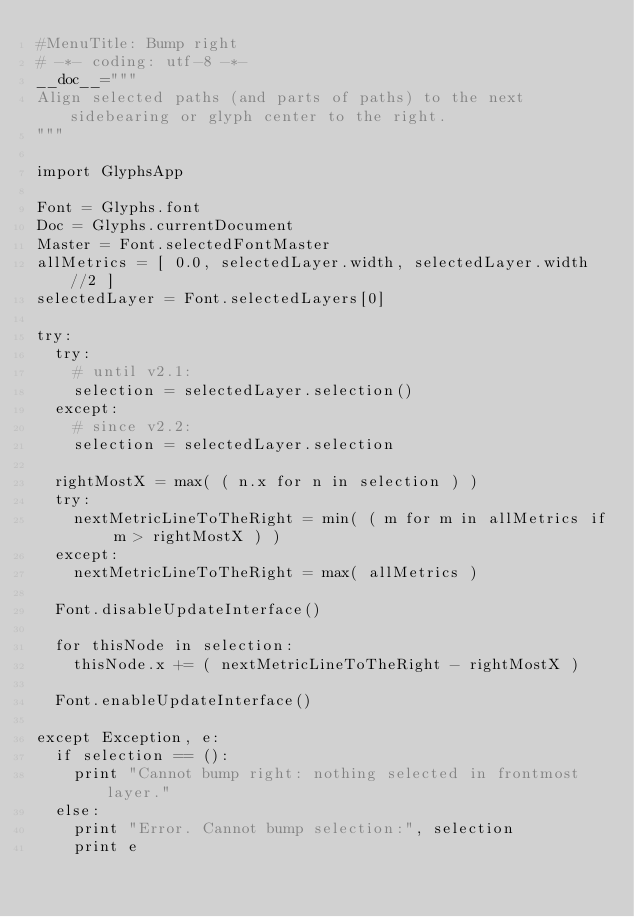Convert code to text. <code><loc_0><loc_0><loc_500><loc_500><_Python_>#MenuTitle: Bump right
# -*- coding: utf-8 -*-
__doc__="""
Align selected paths (and parts of paths) to the next sidebearing or glyph center to the right.
"""

import GlyphsApp

Font = Glyphs.font
Doc = Glyphs.currentDocument
Master = Font.selectedFontMaster
allMetrics = [ 0.0, selectedLayer.width, selectedLayer.width//2 ]
selectedLayer = Font.selectedLayers[0]

try:
	try:
		# until v2.1:
		selection = selectedLayer.selection()
	except:
		# since v2.2:
		selection = selectedLayer.selection
	
	rightMostX = max( ( n.x for n in selection ) )
	try:
		nextMetricLineToTheRight = min( ( m for m in allMetrics if m > rightMostX ) )
	except:
		nextMetricLineToTheRight = max( allMetrics )

	Font.disableUpdateInterface()

	for thisNode in selection:
		thisNode.x += ( nextMetricLineToTheRight - rightMostX )

	Font.enableUpdateInterface()
	
except Exception, e:
	if selection == ():
		print "Cannot bump right: nothing selected in frontmost layer."
	else:
		print "Error. Cannot bump selection:", selection
		print e
</code> 